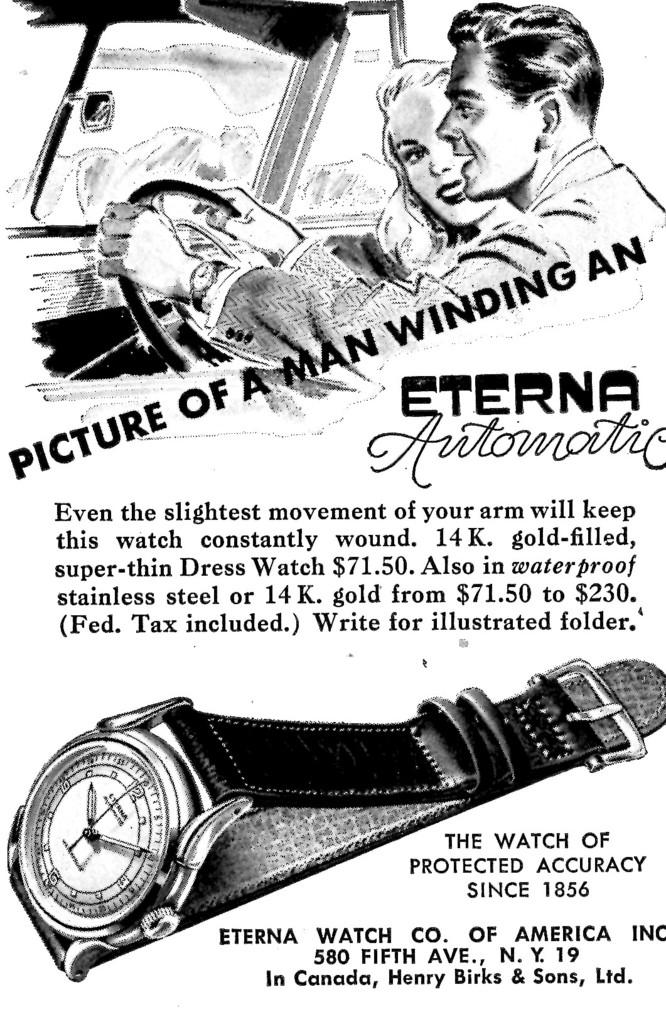Provide a one-sentence caption for the provided image. AN OLD ADVERTISMENT PAGE OF A ETERNA AUTOMATIC WATCH. 